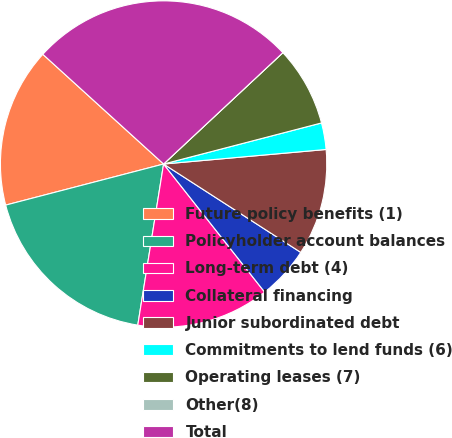Convert chart. <chart><loc_0><loc_0><loc_500><loc_500><pie_chart><fcel>Future policy benefits (1)<fcel>Policyholder account balances<fcel>Long-term debt (4)<fcel>Collateral financing<fcel>Junior subordinated debt<fcel>Commitments to lend funds (6)<fcel>Operating leases (7)<fcel>Other(8)<fcel>Total<nl><fcel>15.79%<fcel>18.42%<fcel>13.16%<fcel>5.26%<fcel>10.53%<fcel>2.63%<fcel>7.9%<fcel>0.0%<fcel>26.31%<nl></chart> 